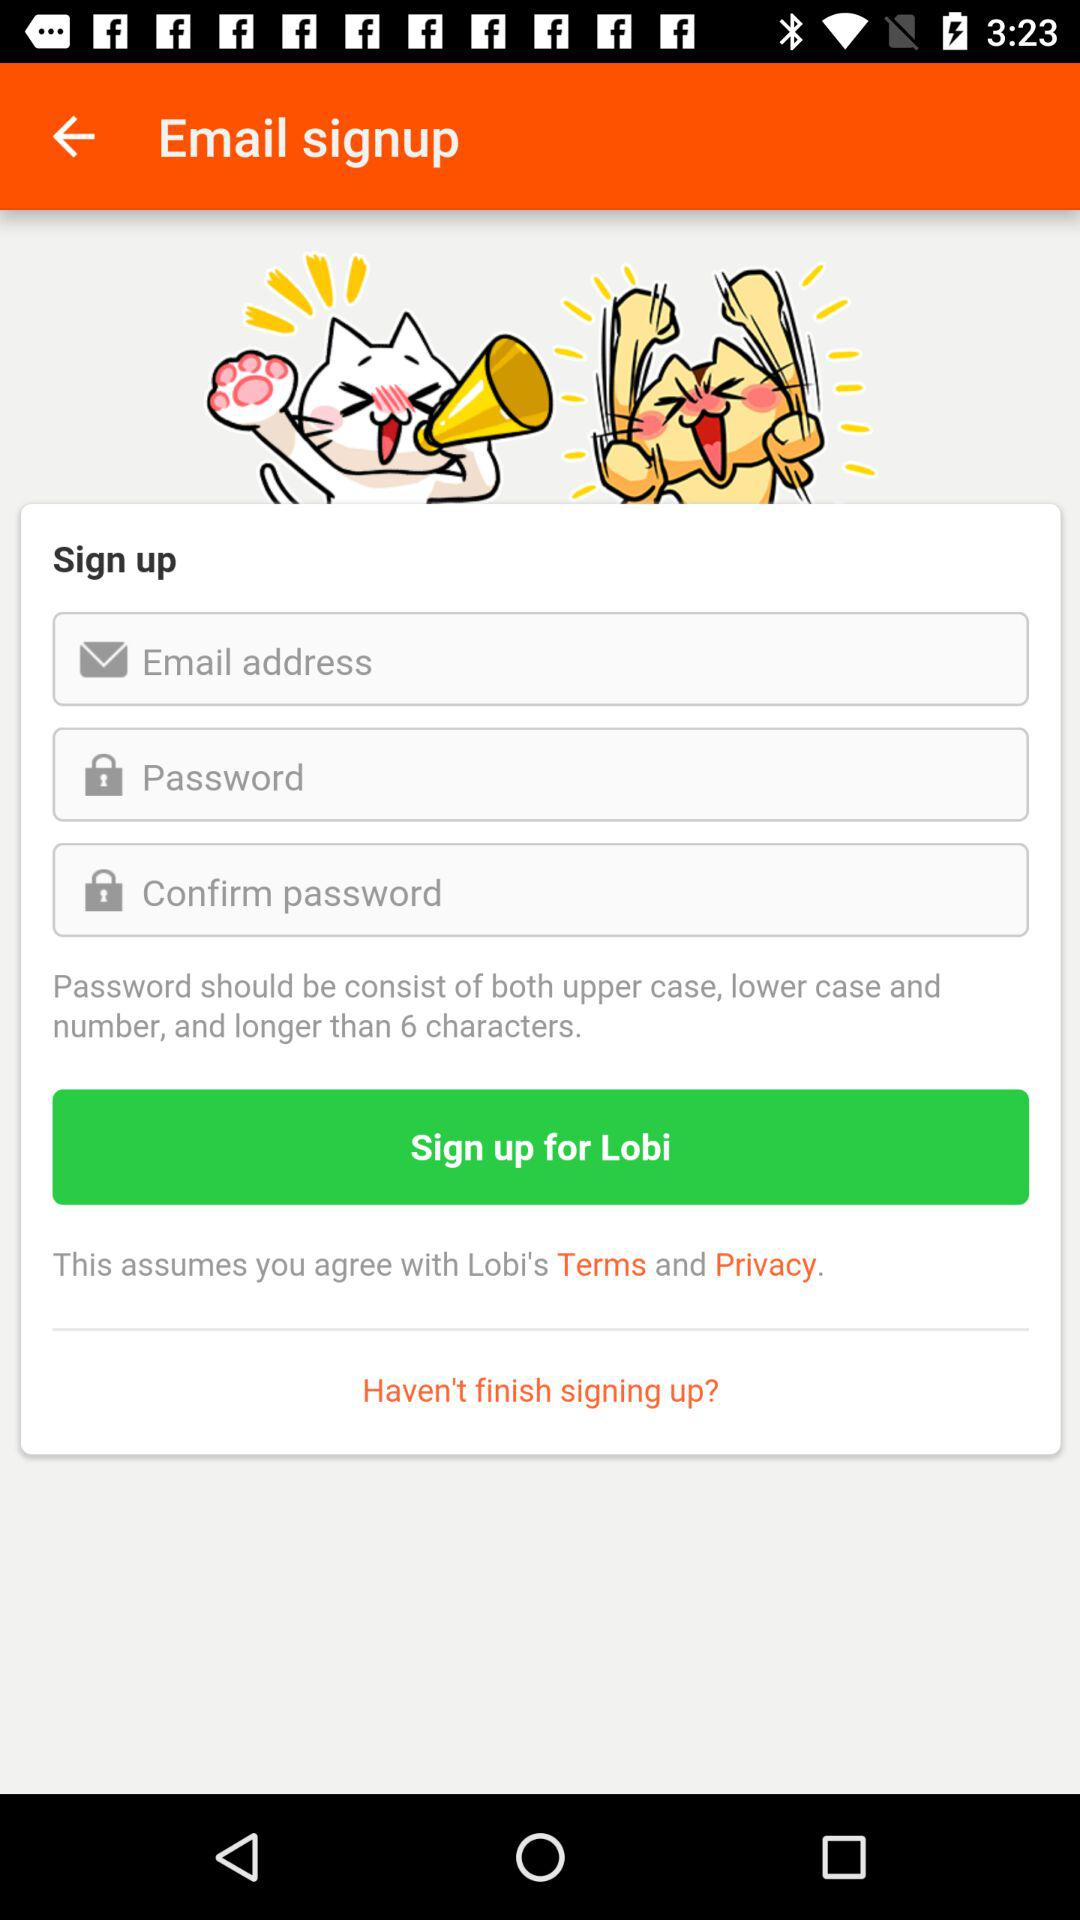What are the criteria required for a password? Password should be consist of both upper case, lower case and number, and longer than 6 characters. 